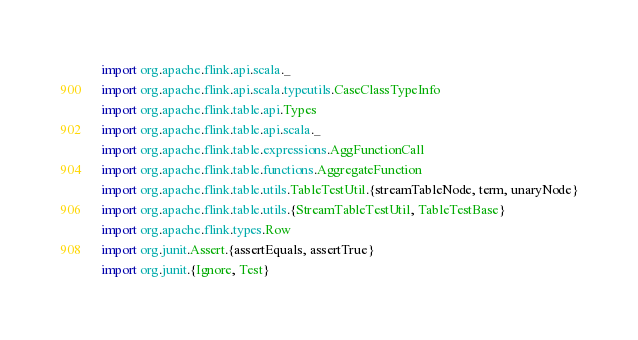Convert code to text. <code><loc_0><loc_0><loc_500><loc_500><_Scala_>import org.apache.flink.api.scala._
import org.apache.flink.api.scala.typeutils.CaseClassTypeInfo
import org.apache.flink.table.api.Types
import org.apache.flink.table.api.scala._
import org.apache.flink.table.expressions.AggFunctionCall
import org.apache.flink.table.functions.AggregateFunction
import org.apache.flink.table.utils.TableTestUtil.{streamTableNode, term, unaryNode}
import org.apache.flink.table.utils.{StreamTableTestUtil, TableTestBase}
import org.apache.flink.types.Row
import org.junit.Assert.{assertEquals, assertTrue}
import org.junit.{Ignore, Test}
</code> 